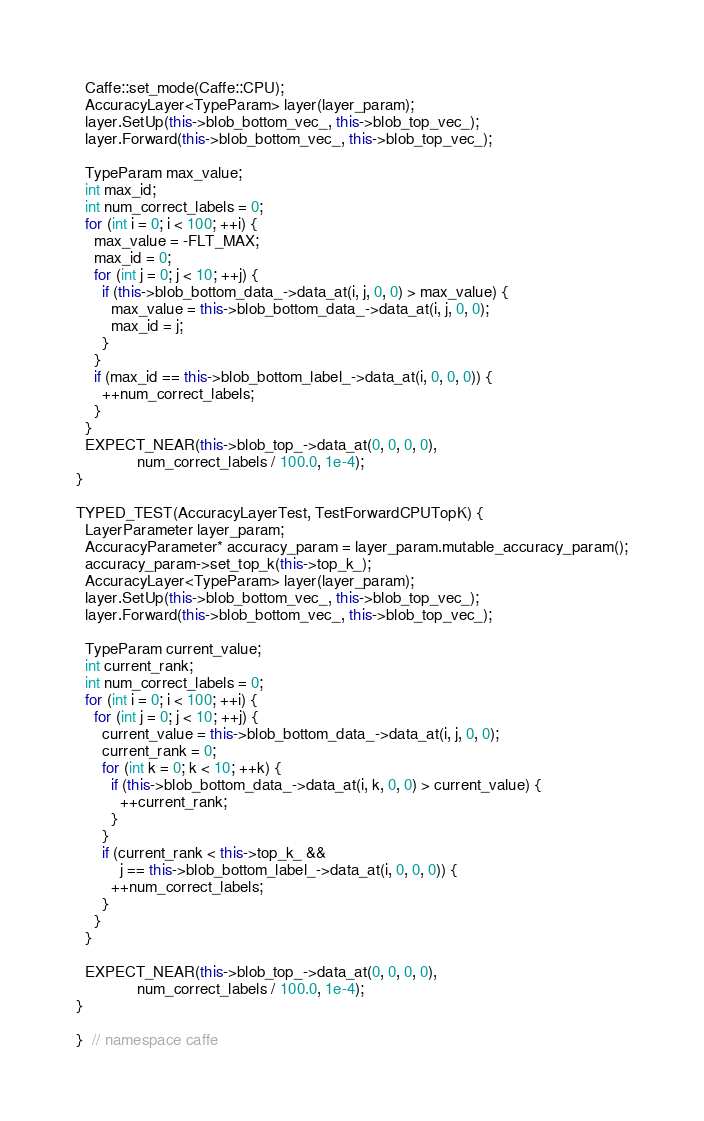Convert code to text. <code><loc_0><loc_0><loc_500><loc_500><_C++_>  Caffe::set_mode(Caffe::CPU);
  AccuracyLayer<TypeParam> layer(layer_param);
  layer.SetUp(this->blob_bottom_vec_, this->blob_top_vec_);
  layer.Forward(this->blob_bottom_vec_, this->blob_top_vec_);

  TypeParam max_value;
  int max_id;
  int num_correct_labels = 0;
  for (int i = 0; i < 100; ++i) {
    max_value = -FLT_MAX;
    max_id = 0;
    for (int j = 0; j < 10; ++j) {
      if (this->blob_bottom_data_->data_at(i, j, 0, 0) > max_value) {
        max_value = this->blob_bottom_data_->data_at(i, j, 0, 0);
        max_id = j;
      }
    }
    if (max_id == this->blob_bottom_label_->data_at(i, 0, 0, 0)) {
      ++num_correct_labels;
    }
  }
  EXPECT_NEAR(this->blob_top_->data_at(0, 0, 0, 0),
              num_correct_labels / 100.0, 1e-4);
}

TYPED_TEST(AccuracyLayerTest, TestForwardCPUTopK) {
  LayerParameter layer_param;
  AccuracyParameter* accuracy_param = layer_param.mutable_accuracy_param();
  accuracy_param->set_top_k(this->top_k_);
  AccuracyLayer<TypeParam> layer(layer_param);
  layer.SetUp(this->blob_bottom_vec_, this->blob_top_vec_);
  layer.Forward(this->blob_bottom_vec_, this->blob_top_vec_);

  TypeParam current_value;
  int current_rank;
  int num_correct_labels = 0;
  for (int i = 0; i < 100; ++i) {
    for (int j = 0; j < 10; ++j) {
      current_value = this->blob_bottom_data_->data_at(i, j, 0, 0);
      current_rank = 0;
      for (int k = 0; k < 10; ++k) {
        if (this->blob_bottom_data_->data_at(i, k, 0, 0) > current_value) {
          ++current_rank;
        }
      }
      if (current_rank < this->top_k_ &&
          j == this->blob_bottom_label_->data_at(i, 0, 0, 0)) {
        ++num_correct_labels;
      }
    }
  }

  EXPECT_NEAR(this->blob_top_->data_at(0, 0, 0, 0),
              num_correct_labels / 100.0, 1e-4);
}

}  // namespace caffe
</code> 